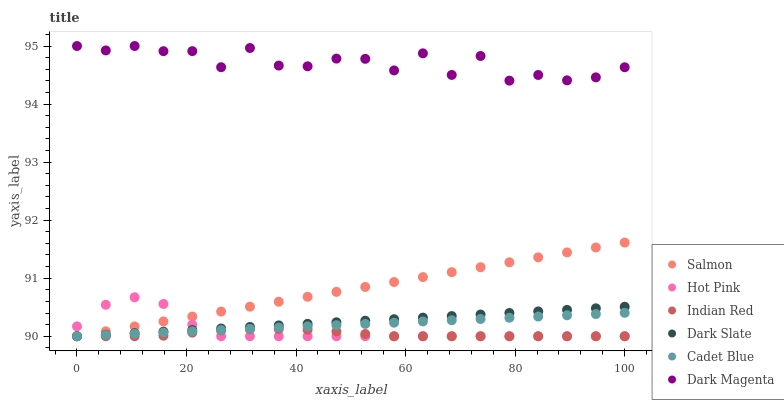Does Indian Red have the minimum area under the curve?
Answer yes or no. Yes. Does Dark Magenta have the maximum area under the curve?
Answer yes or no. Yes. Does Hot Pink have the minimum area under the curve?
Answer yes or no. No. Does Hot Pink have the maximum area under the curve?
Answer yes or no. No. Is Salmon the smoothest?
Answer yes or no. Yes. Is Dark Magenta the roughest?
Answer yes or no. Yes. Is Hot Pink the smoothest?
Answer yes or no. No. Is Hot Pink the roughest?
Answer yes or no. No. Does Cadet Blue have the lowest value?
Answer yes or no. Yes. Does Dark Magenta have the lowest value?
Answer yes or no. No. Does Dark Magenta have the highest value?
Answer yes or no. Yes. Does Hot Pink have the highest value?
Answer yes or no. No. Is Cadet Blue less than Dark Magenta?
Answer yes or no. Yes. Is Dark Magenta greater than Cadet Blue?
Answer yes or no. Yes. Does Cadet Blue intersect Dark Slate?
Answer yes or no. Yes. Is Cadet Blue less than Dark Slate?
Answer yes or no. No. Is Cadet Blue greater than Dark Slate?
Answer yes or no. No. Does Cadet Blue intersect Dark Magenta?
Answer yes or no. No. 